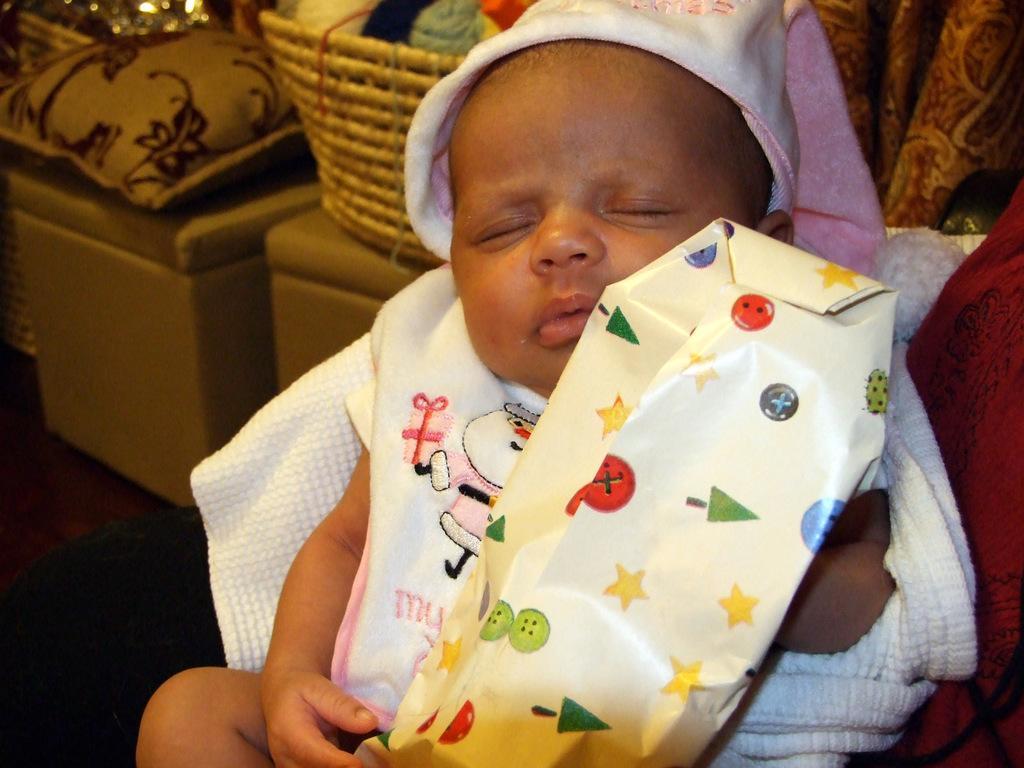How would you summarize this image in a sentence or two? In the image we can see there is a baby sleeping and holding packet. Behind there is basket and pillow kept on the chairs. 